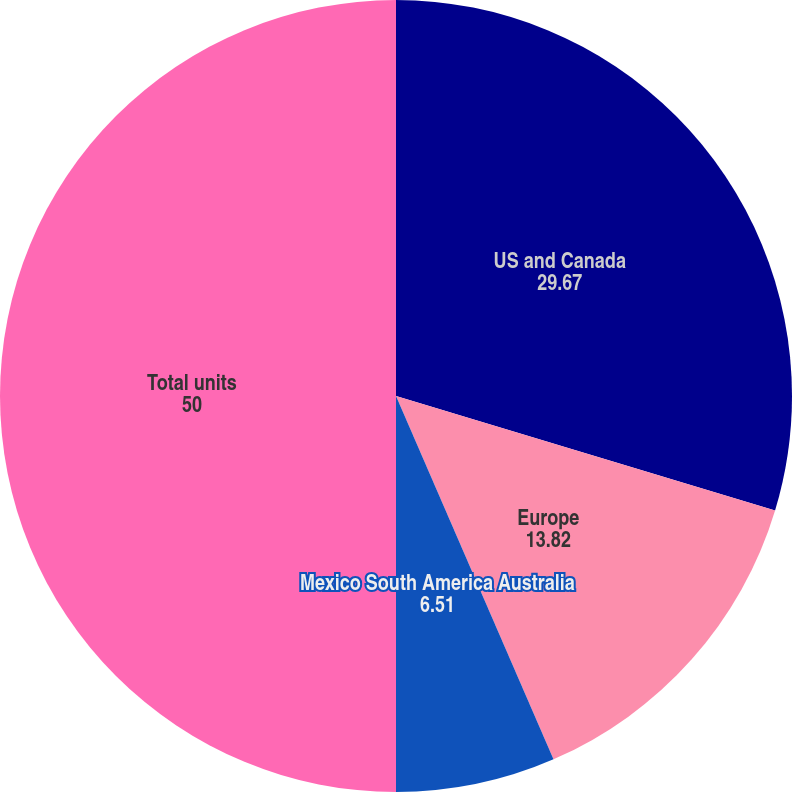<chart> <loc_0><loc_0><loc_500><loc_500><pie_chart><fcel>US and Canada<fcel>Europe<fcel>Mexico South America Australia<fcel>Total units<nl><fcel>29.67%<fcel>13.82%<fcel>6.51%<fcel>50.0%<nl></chart> 